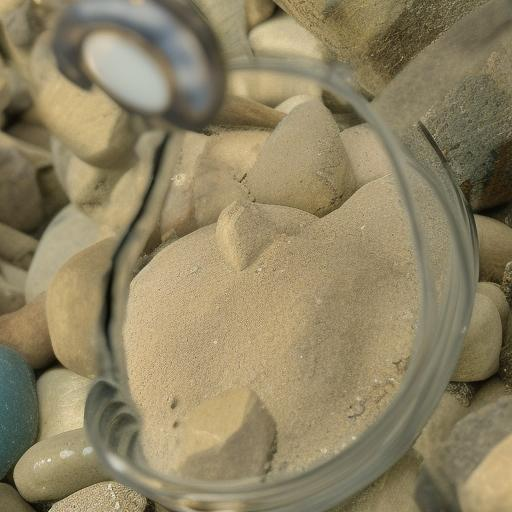What is the color palette of the image?
A. colorful
B. vibrant
C. monotone
Answer with the option's letter from the given choices directly.
 C. 